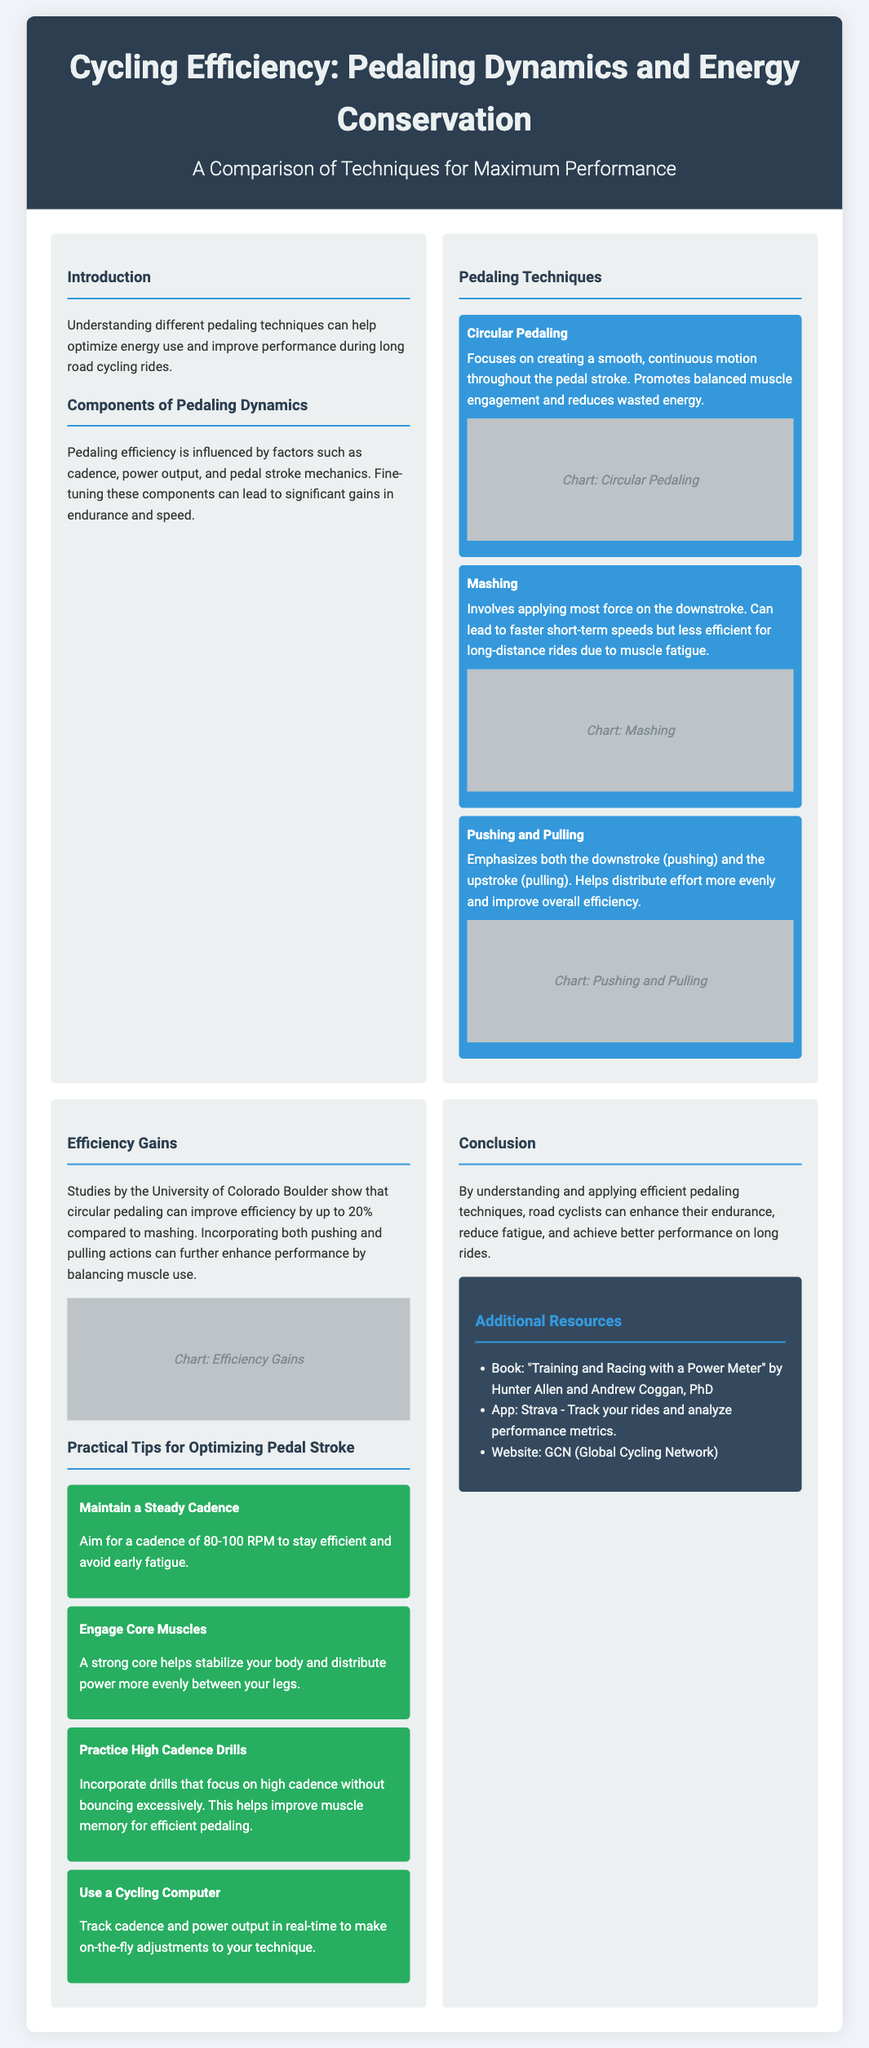What is the main topic of the poster? The main topic is about cycling efficiency, specifically focused on pedaling dynamics and energy conservation.
Answer: Cycling Efficiency: Pedaling Dynamics and Energy Conservation Which technique is said to improve efficiency by up to 20%? Circular pedaling has been shown to improve efficiency by up to 20% compared to mashing.
Answer: Circular Pedaling What cadence is recommended for maintaining efficiency? The poster suggests maintaining a cadence of 80-100 RPM to avoid early fatigue.
Answer: 80-100 RPM Which pedaling technique involves applying most force on the downstroke? The technique referred to is "Mashing," which applies force primarily during the downstroke.
Answer: Mashing What is one practical tip for optimizing pedal stroke? Engaging core muscles is a suggested practical tip for optimizing pedal stroke and stabilizing the body.
Answer: Engage Core Muscles How many pedaling techniques are listed in the document? There are three pedaling techniques presented in the poster.
Answer: Three What resource is recommended for tracking rides and analyzing performance metrics? The app recommended for tracking rides and analyzing performance metrics is Strava.
Answer: Strava What does the sidebar include? The sidebar includes additional resources related to cycling, such as books, apps, and websites.
Answer: Additional Resources 